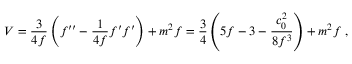<formula> <loc_0><loc_0><loc_500><loc_500>V = { \frac { 3 } { 4 f } } \left ( f ^ { \prime \prime } - { \frac { 1 } { 4 f } } f ^ { \prime } f ^ { \prime } \right ) + m ^ { 2 } f = { \frac { 3 } { 4 } } \left ( 5 f - 3 - { \frac { c _ { 0 } ^ { 2 } } { 8 f ^ { 3 } } } \right ) + m ^ { 2 } f \ ,</formula> 